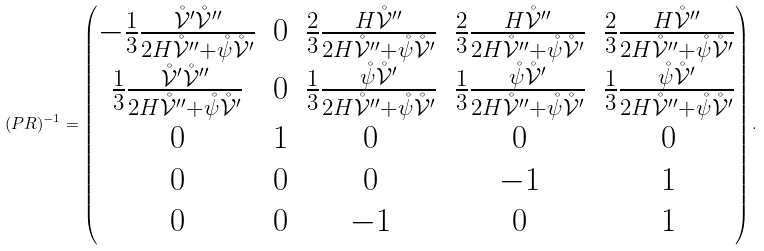<formula> <loc_0><loc_0><loc_500><loc_500>( P R ) ^ { - 1 } = \begin{pmatrix} - \frac { 1 } { 3 } \frac { \mathring { \mathcal { V } } ^ { \prime } \mathring { \mathcal { V } } ^ { \prime \prime } } { 2 H \mathring { \mathcal { V } } ^ { \prime \prime } + \mathring { \psi } \mathring { \mathcal { V } } ^ { \prime } } & 0 & \frac { 2 } { 3 } \frac { H \mathring { \mathcal { V } } ^ { \prime \prime } } { 2 H \mathring { \mathcal { V } } ^ { \prime \prime } + \mathring { \psi } \mathring { \mathcal { V } } ^ { \prime } } & \frac { 2 } { 3 } \frac { H \mathring { \mathcal { V } } ^ { \prime \prime } } { 2 H \mathring { \mathcal { V } } ^ { \prime \prime } + \mathring { \psi } \mathring { \mathcal { V } } ^ { \prime } } & \frac { 2 } { 3 } \frac { H \mathring { \mathcal { V } } ^ { \prime \prime } } { 2 H \mathring { \mathcal { V } } ^ { \prime \prime } + \mathring { \psi } \mathring { \mathcal { V } } ^ { \prime } } \\ \frac { 1 } { 3 } \frac { \mathring { \mathcal { V } } ^ { \prime } \mathring { \mathcal { V } } ^ { \prime \prime } } { 2 H \mathring { \mathcal { V } } ^ { \prime \prime } + \mathring { \psi } \mathring { \mathcal { V } } ^ { \prime } } & 0 & \frac { 1 } { 3 } \frac { \mathring { \psi } \mathring { \mathcal { V } } ^ { \prime } } { 2 H \mathring { \mathcal { V } } ^ { \prime \prime } + \mathring { \psi } \mathring { \mathcal { V } } ^ { \prime } } & \frac { 1 } { 3 } \frac { \mathring { \psi } \mathring { \mathcal { V } } ^ { \prime } } { 2 H \mathring { \mathcal { V } } ^ { \prime \prime } + \mathring { \psi } \mathring { \mathcal { V } } ^ { \prime } } & \frac { 1 } { 3 } \frac { \mathring { \psi } \mathring { \mathcal { V } } ^ { \prime } } { 2 H \mathring { \mathcal { V } } ^ { \prime \prime } + \mathring { \psi } \mathring { \mathcal { V } } ^ { \prime } } \\ 0 & 1 & 0 & 0 & 0 \\ 0 & 0 & 0 & - 1 & 1 \\ 0 & 0 & - 1 & 0 & 1 \end{pmatrix} .</formula> 